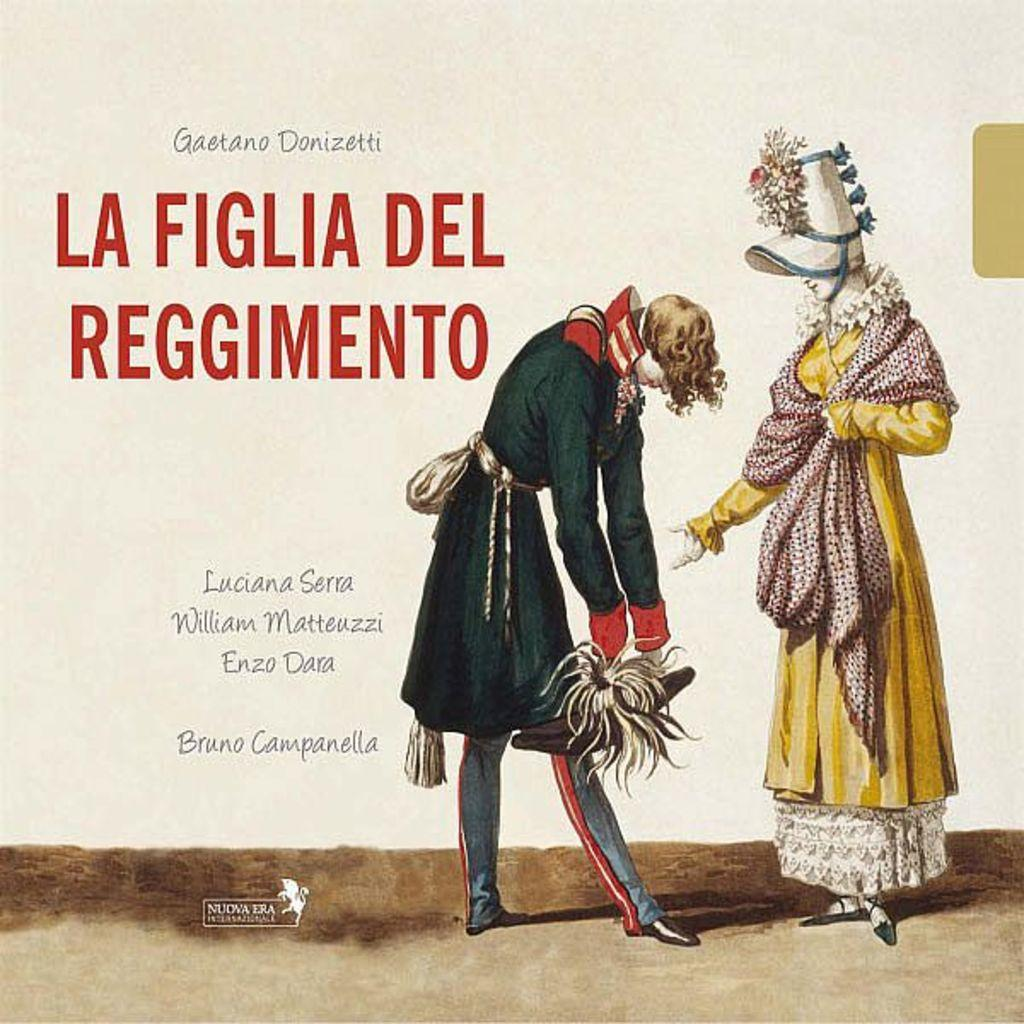What is depicted on the poster in the image? There are people on the poster. What else can be seen on the poster besides the people? There is writing on the poster. How many chickens are present on the poster? There are no chickens depicted on the poster; it features people and writing. What theory is being discussed on the poster? There is no theory mentioned or depicted on the poster; it only shows people and writing. 